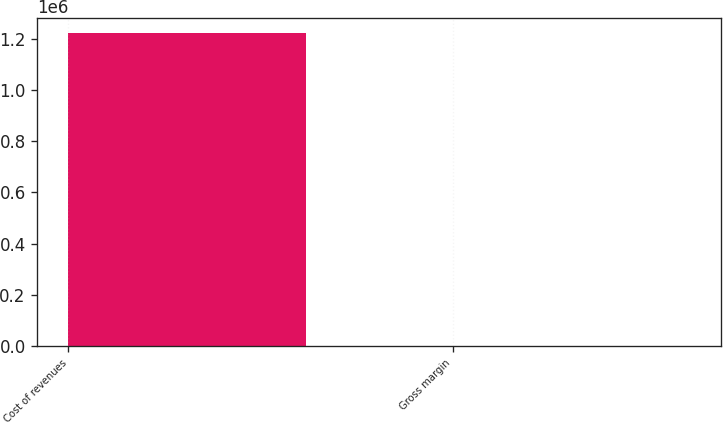Convert chart. <chart><loc_0><loc_0><loc_500><loc_500><bar_chart><fcel>Cost of revenues<fcel>Gross margin<nl><fcel>1.22033e+06<fcel>79<nl></chart> 